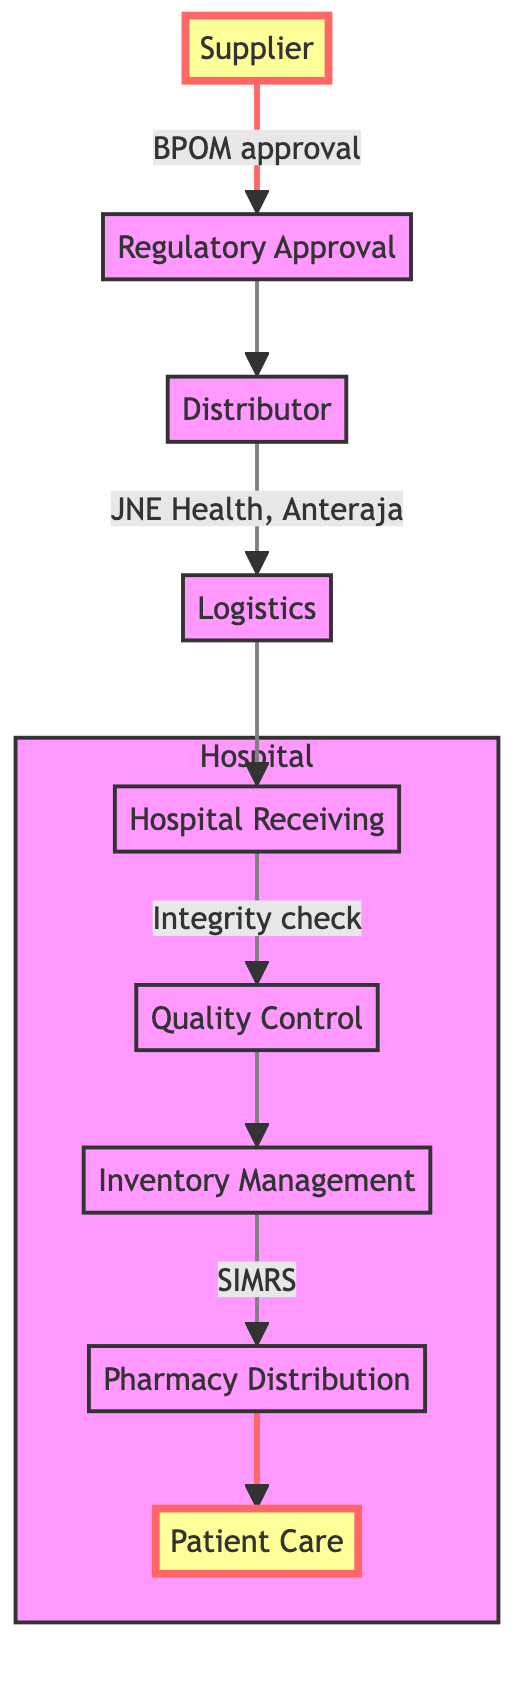What is the first step in the flow chart? The flow chart starts with the "Supplier," indicating that the supply chain begins with pharmaceutical and medical equipment manufacturers.
Answer: Supplier How many major steps are shown in the flow chart? The flow chart has a total of 9 major steps, from Supplier to Patient Care. Each step represents a distinct part of the supply chain process.
Answer: 9 What is the relationship between Distributor and Logistics? The Distributor directly leads to the Logistics, showing that after distributing medical supplies, logistics companies handle transportation and warehousing.
Answer: Distributor to Logistics Which regulatory body is mentioned for ensuring compliance? The regulatory body mentioned is "BPOM," which stands for Badan Pengawas Obat dan Makanan in Indonesia, responsible for drug and food supervision.
Answer: BPOM What ensures the integrity and accuracy of the shipments at the hospital? The "Hospital Receiving" step is responsible for ensuring the integrity and accuracy of shipments before moving on to quality control.
Answer: Hospital Receiving In which step is quality control performed? Quality control is performed in the "Quality Control" step of the flow chart, where the hospital pharmacy's quality control team evaluates received supplies.
Answer: Quality Control What system is used for inventory management in the hospital pharmacy? The system used for inventory management is "SIMRS," which stands for Sistem Informasi Manajemen Rumah Sakit.
Answer: SIMRS Which step comes after Quality Control? After the Quality Control step, the next step is "Inventory Management," indicating that supplies are organized within the hospital pharmacy.
Answer: Inventory Management What is the final step in the supply chain? The final step in the supply chain is "Patient Care," where medical supplies are utilized by health professionals for patient treatment.
Answer: Patient Care 